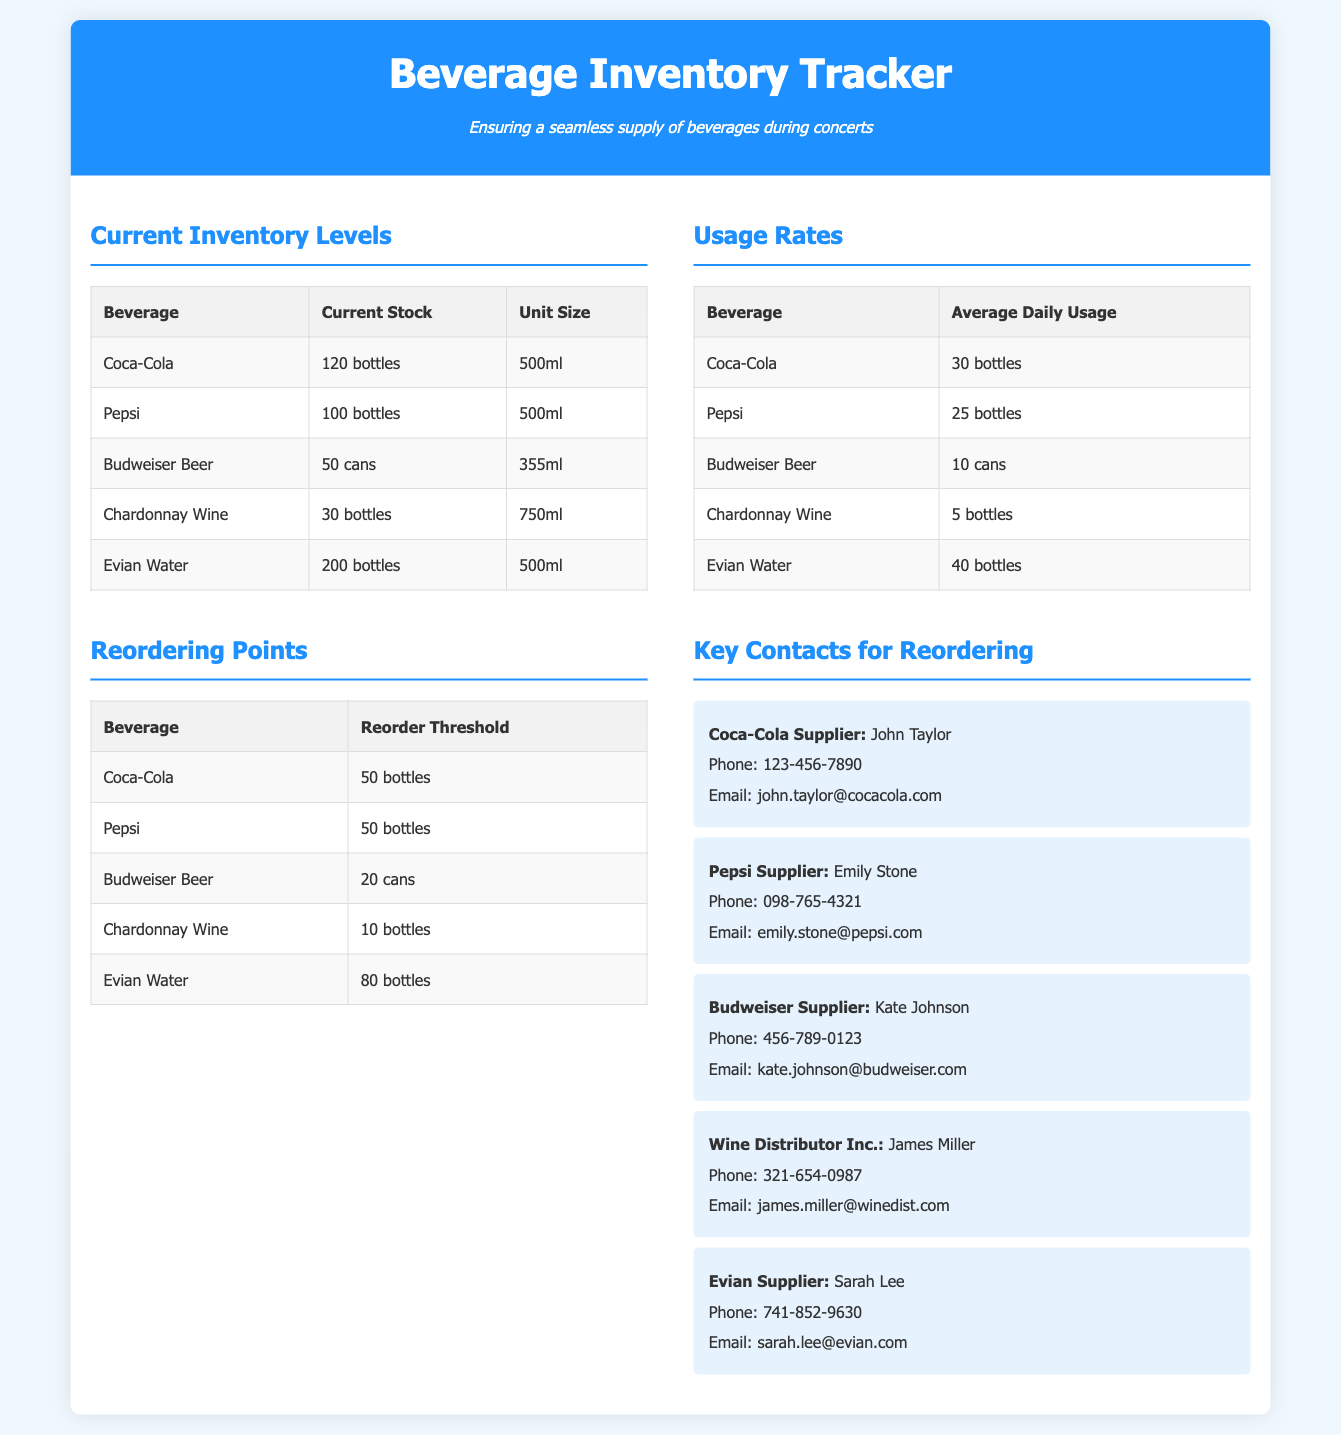What is the total stock of Coca-Cola? The total stock of Coca-Cola is listed in the current inventory table as 120 bottles.
Answer: 120 bottles What is the average daily usage of Evian Water? The average daily usage of Evian Water is provided in the usage rates table as 40 bottles.
Answer: 40 bottles What is the reorder threshold for Budweiser Beer? The reorder threshold for Budweiser Beer is found in the reordering points table, which states it is 20 cans.
Answer: 20 cans Who is the supplier for Chardonnay Wine? The supplier for Chardonnay Wine is detailed in the key contacts section as James Miller from Wine Distributor Inc.
Answer: James Miller How many bottles of Pepsi are currently in stock? The current stock of Pepsi is listed in the inventory levels section as 100 bottles.
Answer: 100 bottles Which beverage has the highest current stock? By comparing the current stock levels, Evian Water is found to have the highest current stock at 200 bottles.
Answer: Evian Water What is the unit size for Budweiser Beer? The unit size for Budweiser Beer is specified in the inventory levels table as 355ml.
Answer: 355ml If the average daily usage of Chardonnay Wine is 5 bottles, how many days will the current stock last? The current stock of Chardonnay Wine is 30 bottles, and dividing this by the daily usage of 5 bottles gives 6 days.
Answer: 6 days What color is used for the header background? The header background color is presented in the document as #1e90ff, which is a shade of blue.
Answer: blue 